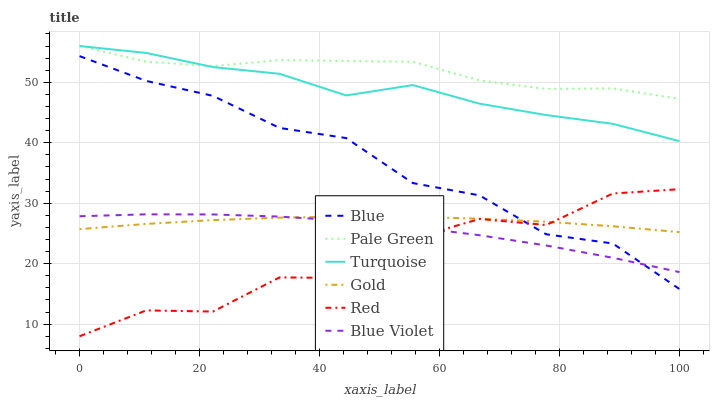Does Red have the minimum area under the curve?
Answer yes or no. Yes. Does Pale Green have the maximum area under the curve?
Answer yes or no. Yes. Does Turquoise have the minimum area under the curve?
Answer yes or no. No. Does Turquoise have the maximum area under the curve?
Answer yes or no. No. Is Gold the smoothest?
Answer yes or no. Yes. Is Red the roughest?
Answer yes or no. Yes. Is Turquoise the smoothest?
Answer yes or no. No. Is Turquoise the roughest?
Answer yes or no. No. Does Red have the lowest value?
Answer yes or no. Yes. Does Turquoise have the lowest value?
Answer yes or no. No. Does Pale Green have the highest value?
Answer yes or no. Yes. Does Gold have the highest value?
Answer yes or no. No. Is Blue Violet less than Pale Green?
Answer yes or no. Yes. Is Turquoise greater than Blue?
Answer yes or no. Yes. Does Gold intersect Blue?
Answer yes or no. Yes. Is Gold less than Blue?
Answer yes or no. No. Is Gold greater than Blue?
Answer yes or no. No. Does Blue Violet intersect Pale Green?
Answer yes or no. No. 